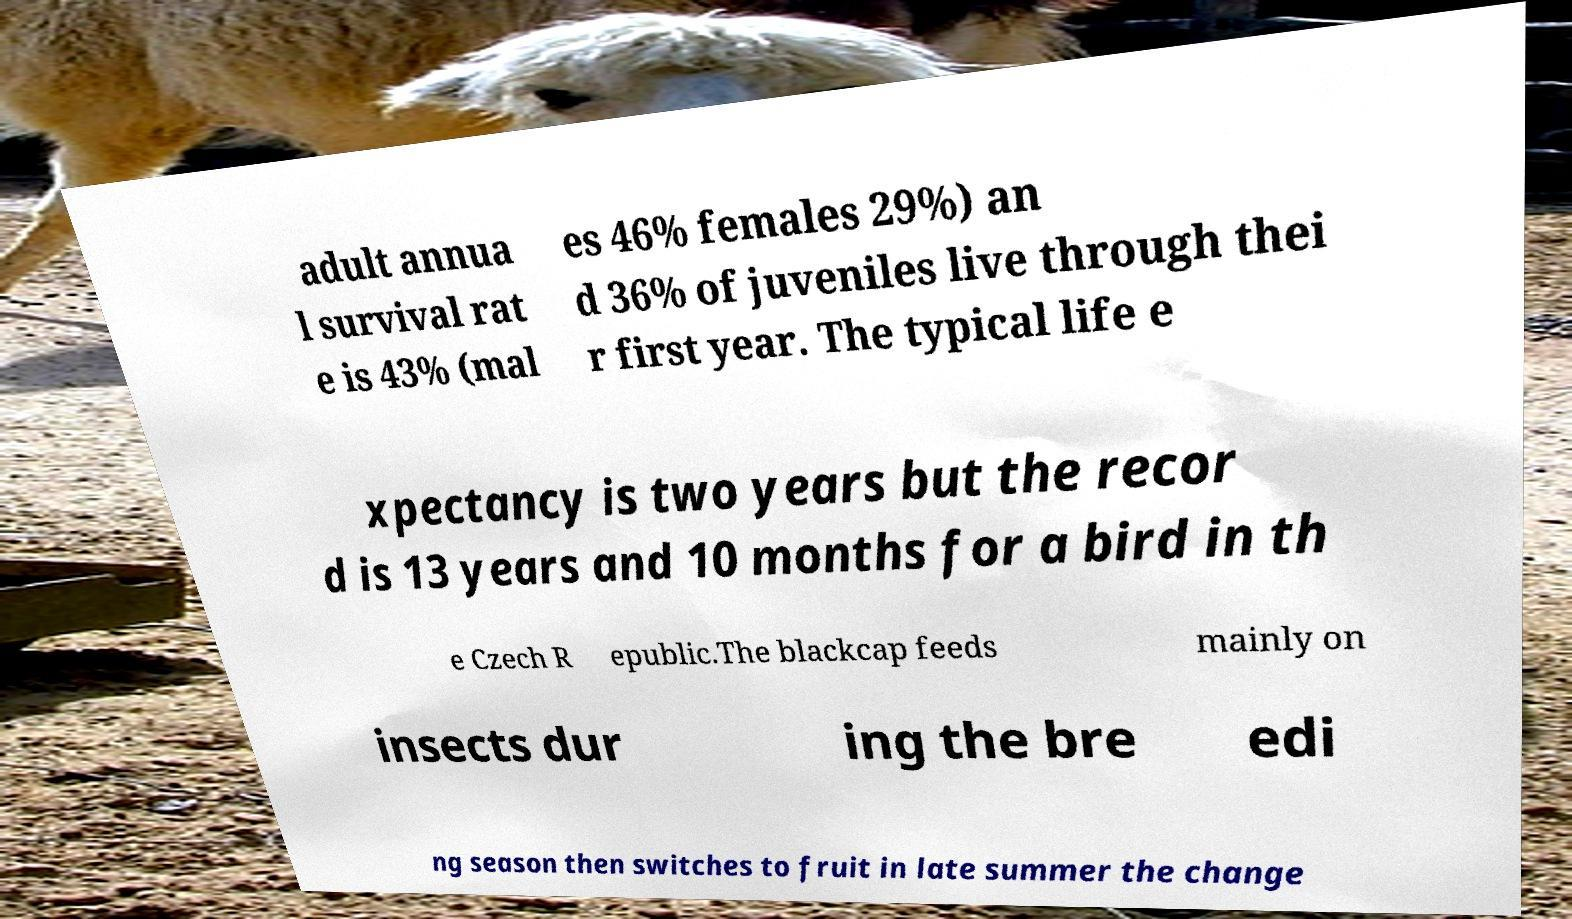Could you extract and type out the text from this image? adult annua l survival rat e is 43% (mal es 46% females 29%) an d 36% of juveniles live through thei r first year. The typical life e xpectancy is two years but the recor d is 13 years and 10 months for a bird in th e Czech R epublic.The blackcap feeds mainly on insects dur ing the bre edi ng season then switches to fruit in late summer the change 